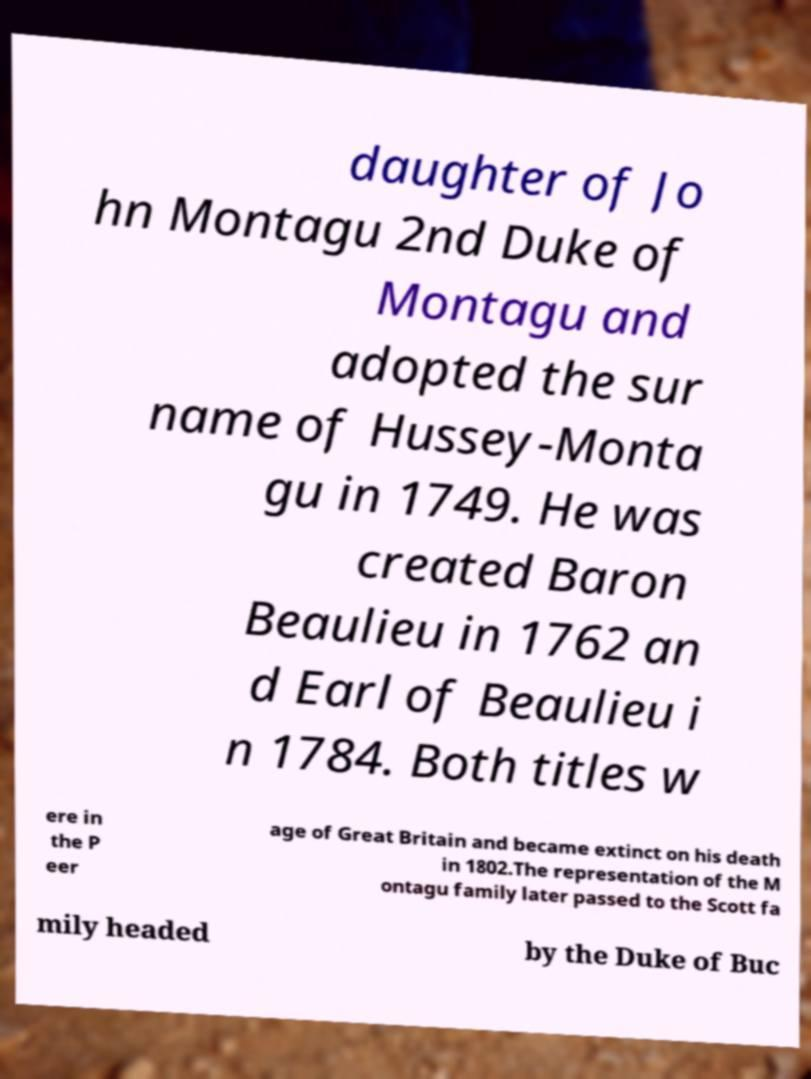Please read and relay the text visible in this image. What does it say? daughter of Jo hn Montagu 2nd Duke of Montagu and adopted the sur name of Hussey-Monta gu in 1749. He was created Baron Beaulieu in 1762 an d Earl of Beaulieu i n 1784. Both titles w ere in the P eer age of Great Britain and became extinct on his death in 1802.The representation of the M ontagu family later passed to the Scott fa mily headed by the Duke of Buc 